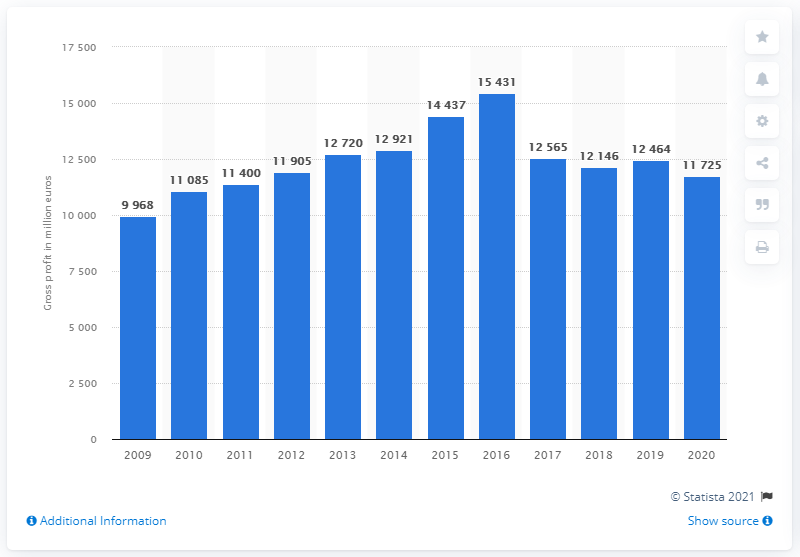Outline some significant characteristics in this image. In the previous year, IKEA's global gross profit was 124,641. In 2020, IKEA's global gross profit was 117,250. 